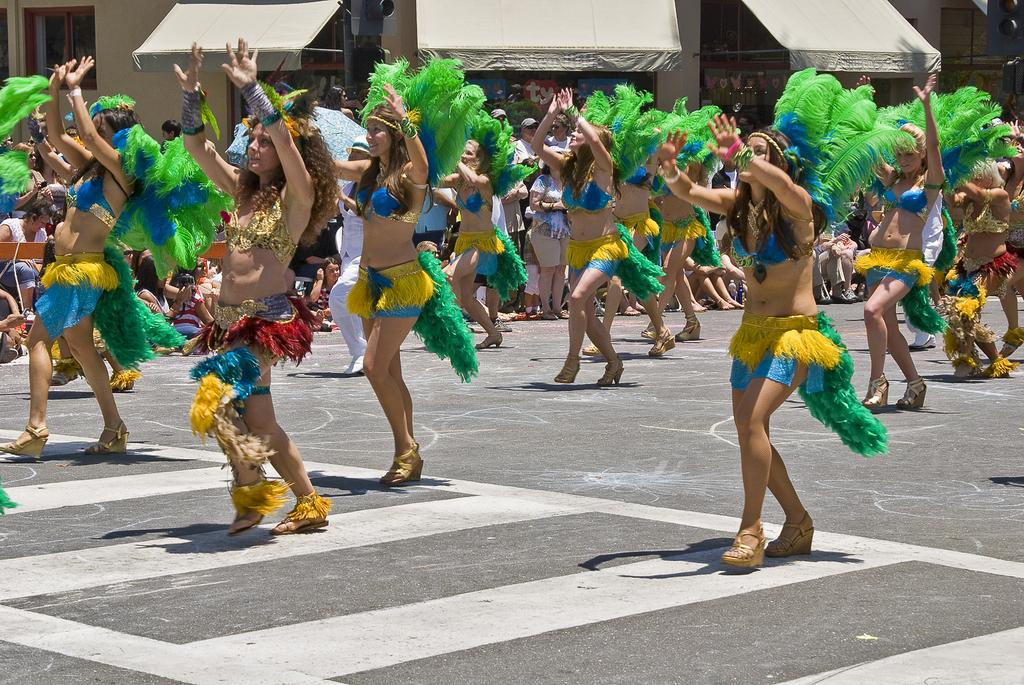What are the women in the image doing? The women in the image are dancing. Where are the women dancing? The women are dancing on the road. What can be seen in the image besides the dancing women? Sunshades and a building with windows are visible in the image. Are there any other people in the image besides the dancing women? Yes, there are people standing in the image. What riddle is the grandfather telling the people in the image? There is no grandfather or riddle present in the image. What is the name of the downtown area where the dancing is taking place in the image? The image does not specify a downtown area, and the location of the dancing is not mentioned. 